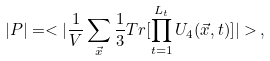Convert formula to latex. <formula><loc_0><loc_0><loc_500><loc_500>| P | = < | \frac { 1 } { V } \sum _ { \vec { x } } \frac { 1 } { 3 } T r [ \prod _ { t = 1 } ^ { L _ { t } } U _ { 4 } ( \vec { x } , t ) ] | > \, ,</formula> 